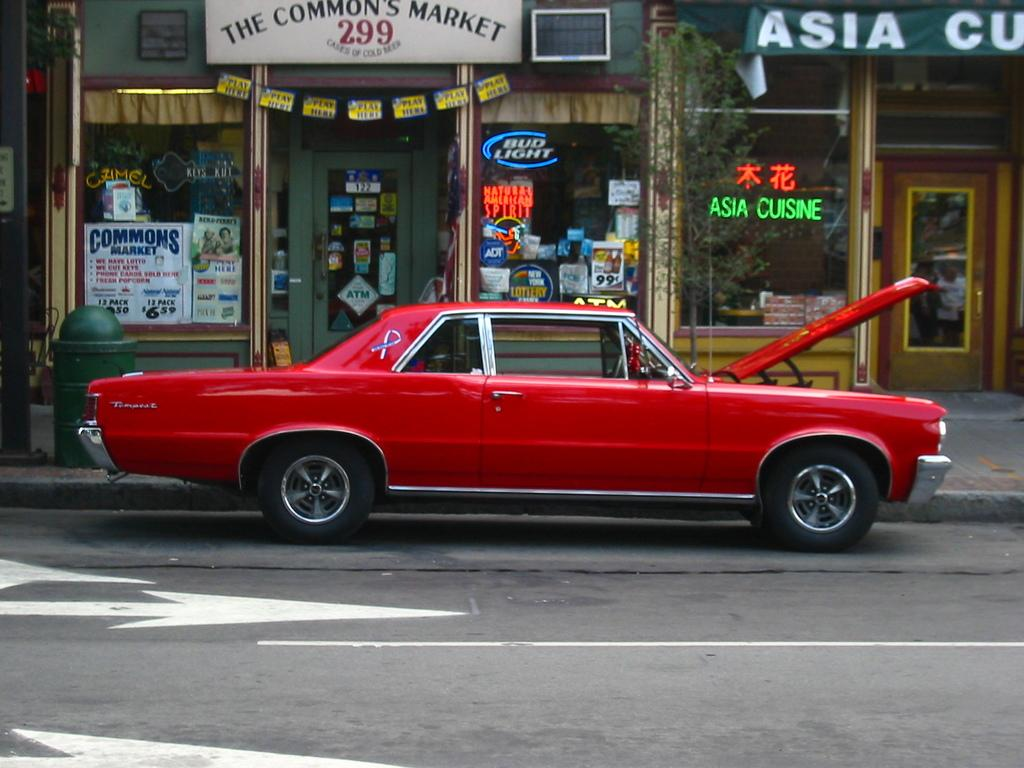<image>
Share a concise interpretation of the image provided. A red vintage car is parked in front of The Common's Market. 